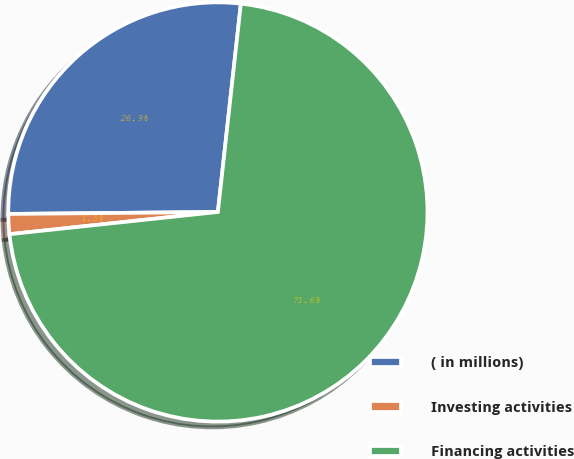<chart> <loc_0><loc_0><loc_500><loc_500><pie_chart><fcel>( in millions)<fcel>Investing activities<fcel>Financing activities<nl><fcel>26.9%<fcel>1.54%<fcel>71.56%<nl></chart> 